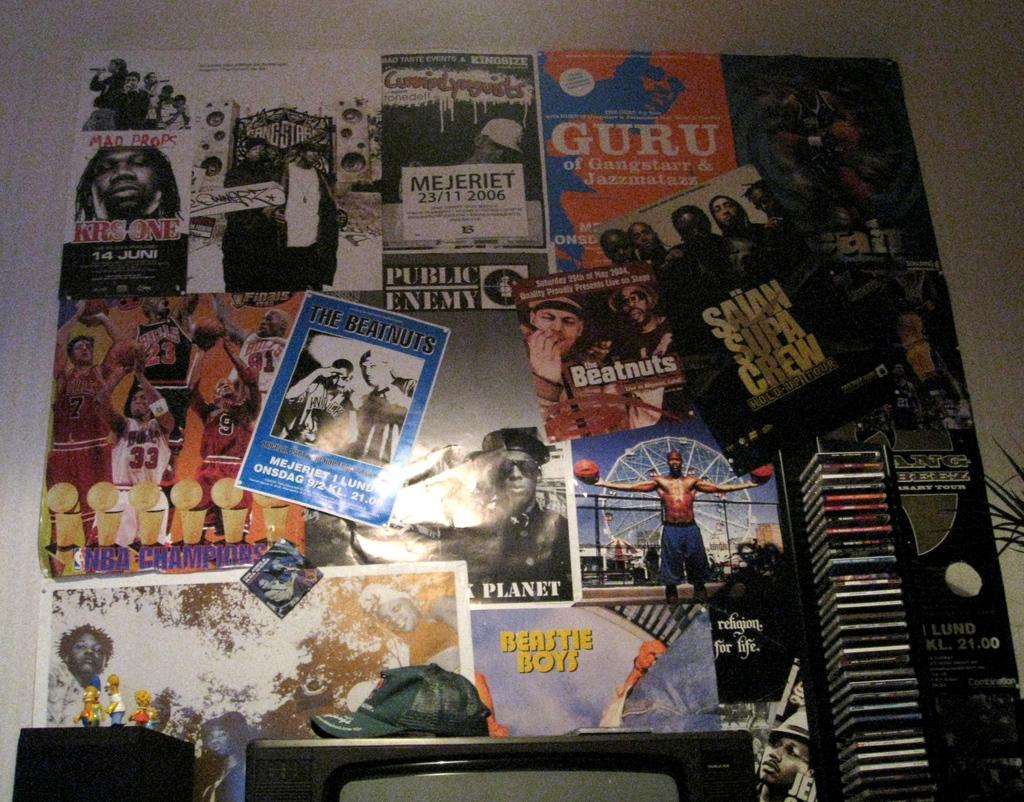What is hanging on the wall in the center of the image? There are posters on the wall in the center of the image. What objects are located at the bottom of the image? There is a speaker, a television, a cap, CDs, and a plant at the bottom of the image. What language is being spoken in the church depicted in the image? There is no church or language spoken in the image; it features posters on the wall, a speaker, a television, a cap, CDs, and a plant at the bottom. What type of table is visible in the image? There is no table present in the image. 